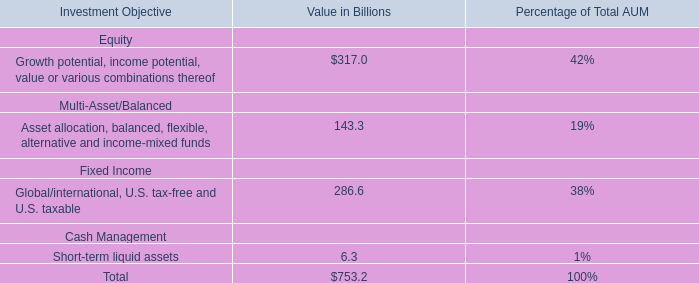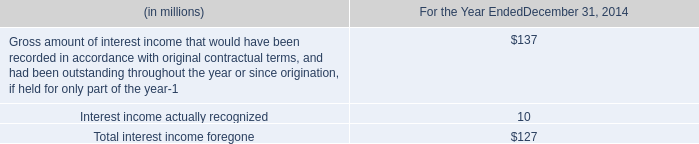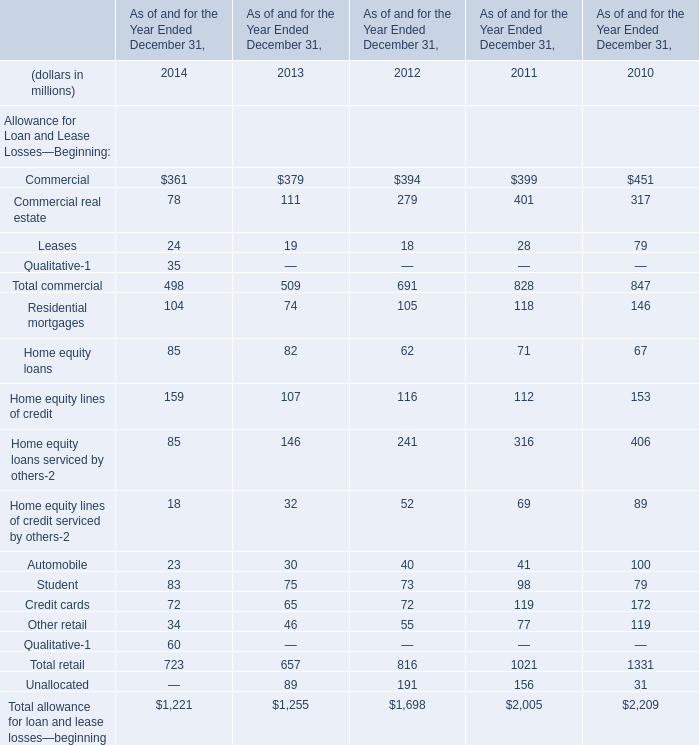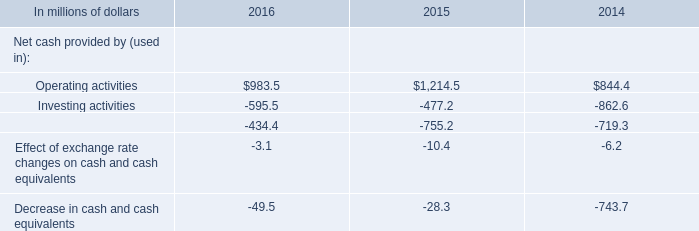What is the sum of Commercial in 2014 for Allowance for Loan and Lease Losses—Beginning and Operating activities in 2016 for Net cash provided by (used in)? (in million) 
Computations: (361 + 983.5)
Answer: 1344.5. 